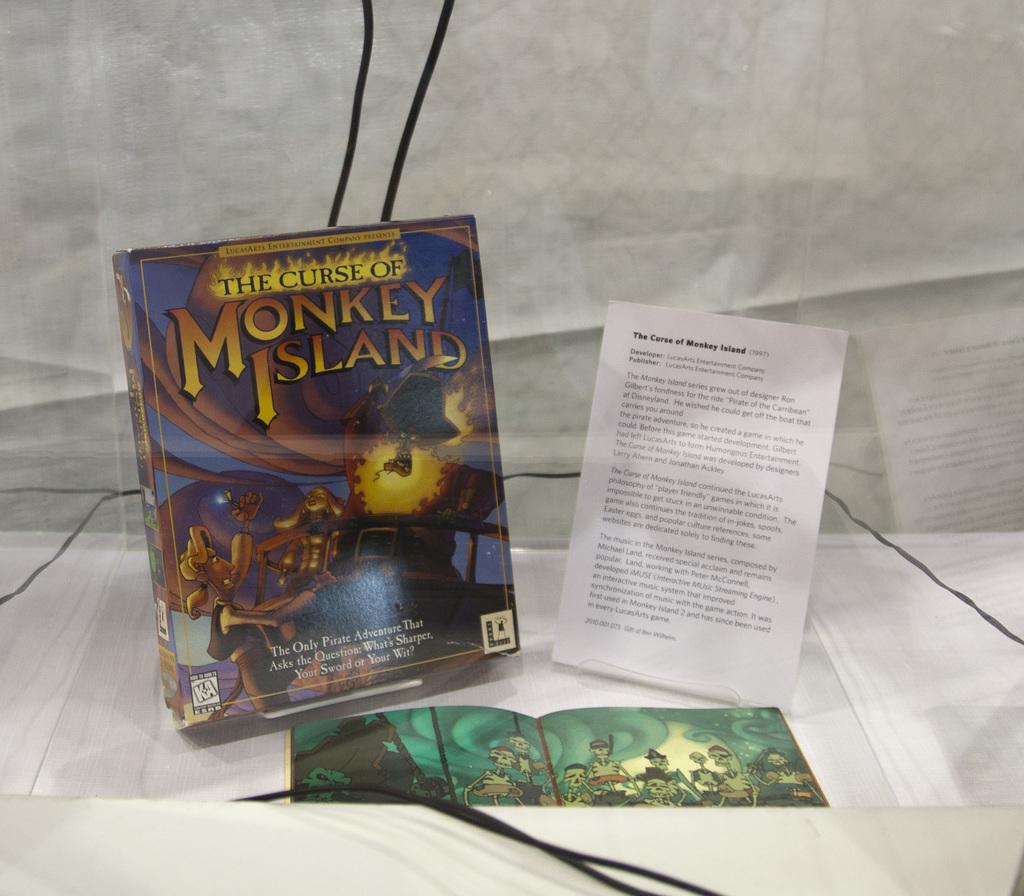What type of adventure is in the book?
Offer a very short reply. Pirate. 